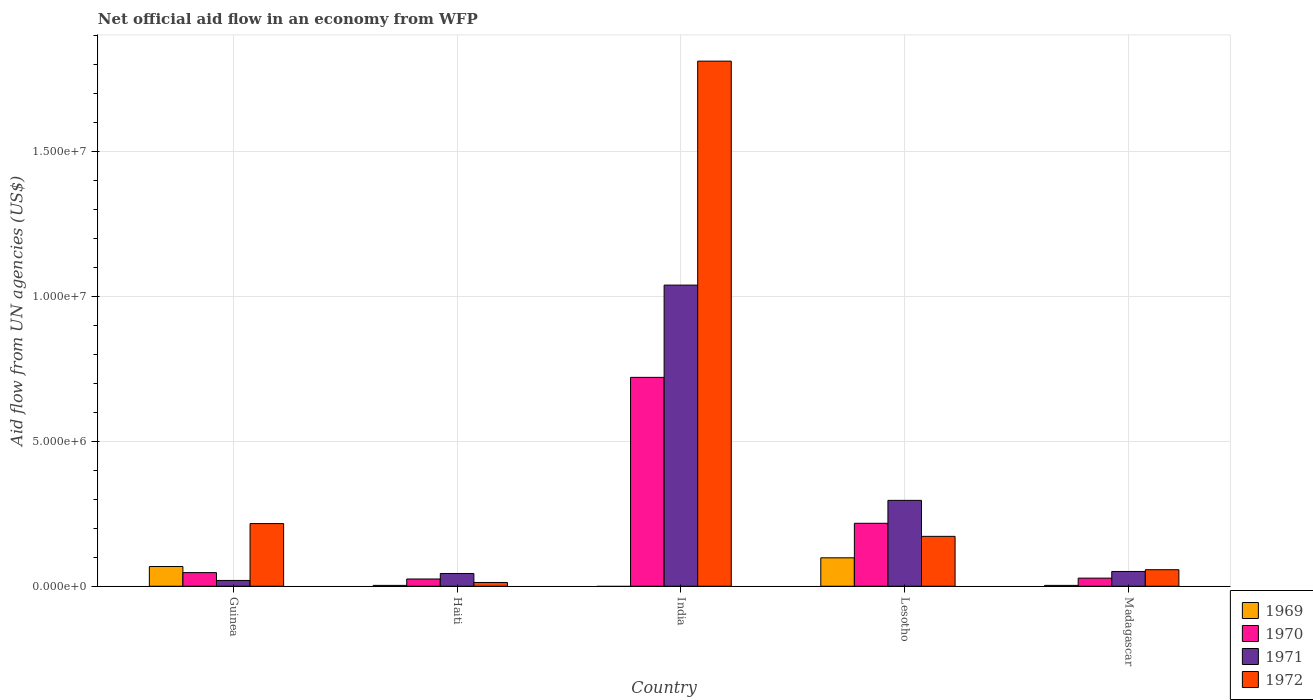How many different coloured bars are there?
Provide a succinct answer. 4. Are the number of bars per tick equal to the number of legend labels?
Your answer should be compact. No. How many bars are there on the 3rd tick from the right?
Provide a succinct answer. 3. What is the label of the 5th group of bars from the left?
Make the answer very short. Madagascar. Across all countries, what is the maximum net official aid flow in 1970?
Provide a short and direct response. 7.20e+06. Across all countries, what is the minimum net official aid flow in 1969?
Offer a very short reply. 0. In which country was the net official aid flow in 1972 maximum?
Offer a terse response. India. What is the total net official aid flow in 1970 in the graph?
Provide a short and direct response. 1.04e+07. What is the difference between the net official aid flow in 1971 in Lesotho and that in Madagascar?
Your response must be concise. 2.45e+06. What is the difference between the net official aid flow in 1969 in Lesotho and the net official aid flow in 1970 in Guinea?
Make the answer very short. 5.10e+05. What is the average net official aid flow in 1971 per country?
Your response must be concise. 2.90e+06. In how many countries, is the net official aid flow in 1972 greater than 10000000 US$?
Provide a short and direct response. 1. What is the ratio of the net official aid flow in 1969 in Lesotho to that in Madagascar?
Provide a short and direct response. 32.67. Is the net official aid flow in 1972 in Haiti less than that in India?
Ensure brevity in your answer.  Yes. What is the difference between the highest and the second highest net official aid flow in 1972?
Provide a short and direct response. 1.59e+07. What is the difference between the highest and the lowest net official aid flow in 1972?
Offer a very short reply. 1.80e+07. In how many countries, is the net official aid flow in 1972 greater than the average net official aid flow in 1972 taken over all countries?
Provide a short and direct response. 1. Is it the case that in every country, the sum of the net official aid flow in 1972 and net official aid flow in 1969 is greater than the net official aid flow in 1970?
Offer a very short reply. No. How many bars are there?
Your response must be concise. 19. How many countries are there in the graph?
Your answer should be very brief. 5. Does the graph contain grids?
Provide a short and direct response. Yes. How many legend labels are there?
Your response must be concise. 4. How are the legend labels stacked?
Ensure brevity in your answer.  Vertical. What is the title of the graph?
Your answer should be very brief. Net official aid flow in an economy from WFP. Does "1960" appear as one of the legend labels in the graph?
Provide a short and direct response. No. What is the label or title of the X-axis?
Ensure brevity in your answer.  Country. What is the label or title of the Y-axis?
Ensure brevity in your answer.  Aid flow from UN agencies (US$). What is the Aid flow from UN agencies (US$) in 1969 in Guinea?
Provide a short and direct response. 6.80e+05. What is the Aid flow from UN agencies (US$) in 1970 in Guinea?
Offer a very short reply. 4.70e+05. What is the Aid flow from UN agencies (US$) of 1971 in Guinea?
Provide a short and direct response. 2.00e+05. What is the Aid flow from UN agencies (US$) in 1972 in Guinea?
Ensure brevity in your answer.  2.16e+06. What is the Aid flow from UN agencies (US$) of 1969 in Haiti?
Your answer should be very brief. 3.00e+04. What is the Aid flow from UN agencies (US$) of 1970 in Haiti?
Your answer should be very brief. 2.50e+05. What is the Aid flow from UN agencies (US$) of 1971 in Haiti?
Your response must be concise. 4.40e+05. What is the Aid flow from UN agencies (US$) in 1972 in Haiti?
Offer a terse response. 1.30e+05. What is the Aid flow from UN agencies (US$) of 1970 in India?
Offer a terse response. 7.20e+06. What is the Aid flow from UN agencies (US$) in 1971 in India?
Provide a succinct answer. 1.04e+07. What is the Aid flow from UN agencies (US$) in 1972 in India?
Ensure brevity in your answer.  1.81e+07. What is the Aid flow from UN agencies (US$) of 1969 in Lesotho?
Give a very brief answer. 9.80e+05. What is the Aid flow from UN agencies (US$) of 1970 in Lesotho?
Provide a succinct answer. 2.17e+06. What is the Aid flow from UN agencies (US$) in 1971 in Lesotho?
Give a very brief answer. 2.96e+06. What is the Aid flow from UN agencies (US$) of 1972 in Lesotho?
Your answer should be very brief. 1.72e+06. What is the Aid flow from UN agencies (US$) of 1970 in Madagascar?
Offer a terse response. 2.80e+05. What is the Aid flow from UN agencies (US$) in 1971 in Madagascar?
Your answer should be very brief. 5.10e+05. What is the Aid flow from UN agencies (US$) of 1972 in Madagascar?
Offer a terse response. 5.70e+05. Across all countries, what is the maximum Aid flow from UN agencies (US$) in 1969?
Your answer should be very brief. 9.80e+05. Across all countries, what is the maximum Aid flow from UN agencies (US$) of 1970?
Your answer should be very brief. 7.20e+06. Across all countries, what is the maximum Aid flow from UN agencies (US$) in 1971?
Offer a very short reply. 1.04e+07. Across all countries, what is the maximum Aid flow from UN agencies (US$) of 1972?
Provide a short and direct response. 1.81e+07. Across all countries, what is the minimum Aid flow from UN agencies (US$) of 1969?
Your answer should be very brief. 0. What is the total Aid flow from UN agencies (US$) in 1969 in the graph?
Your answer should be very brief. 1.72e+06. What is the total Aid flow from UN agencies (US$) of 1970 in the graph?
Offer a very short reply. 1.04e+07. What is the total Aid flow from UN agencies (US$) in 1971 in the graph?
Offer a terse response. 1.45e+07. What is the total Aid flow from UN agencies (US$) in 1972 in the graph?
Offer a very short reply. 2.27e+07. What is the difference between the Aid flow from UN agencies (US$) in 1969 in Guinea and that in Haiti?
Offer a very short reply. 6.50e+05. What is the difference between the Aid flow from UN agencies (US$) of 1971 in Guinea and that in Haiti?
Give a very brief answer. -2.40e+05. What is the difference between the Aid flow from UN agencies (US$) of 1972 in Guinea and that in Haiti?
Provide a short and direct response. 2.03e+06. What is the difference between the Aid flow from UN agencies (US$) of 1970 in Guinea and that in India?
Make the answer very short. -6.73e+06. What is the difference between the Aid flow from UN agencies (US$) of 1971 in Guinea and that in India?
Your answer should be very brief. -1.02e+07. What is the difference between the Aid flow from UN agencies (US$) in 1972 in Guinea and that in India?
Your response must be concise. -1.59e+07. What is the difference between the Aid flow from UN agencies (US$) of 1970 in Guinea and that in Lesotho?
Your answer should be very brief. -1.70e+06. What is the difference between the Aid flow from UN agencies (US$) in 1971 in Guinea and that in Lesotho?
Make the answer very short. -2.76e+06. What is the difference between the Aid flow from UN agencies (US$) in 1969 in Guinea and that in Madagascar?
Offer a very short reply. 6.50e+05. What is the difference between the Aid flow from UN agencies (US$) in 1971 in Guinea and that in Madagascar?
Offer a terse response. -3.10e+05. What is the difference between the Aid flow from UN agencies (US$) in 1972 in Guinea and that in Madagascar?
Your answer should be very brief. 1.59e+06. What is the difference between the Aid flow from UN agencies (US$) of 1970 in Haiti and that in India?
Provide a short and direct response. -6.95e+06. What is the difference between the Aid flow from UN agencies (US$) in 1971 in Haiti and that in India?
Provide a short and direct response. -9.94e+06. What is the difference between the Aid flow from UN agencies (US$) in 1972 in Haiti and that in India?
Your answer should be compact. -1.80e+07. What is the difference between the Aid flow from UN agencies (US$) in 1969 in Haiti and that in Lesotho?
Provide a succinct answer. -9.50e+05. What is the difference between the Aid flow from UN agencies (US$) of 1970 in Haiti and that in Lesotho?
Provide a succinct answer. -1.92e+06. What is the difference between the Aid flow from UN agencies (US$) of 1971 in Haiti and that in Lesotho?
Your answer should be compact. -2.52e+06. What is the difference between the Aid flow from UN agencies (US$) of 1972 in Haiti and that in Lesotho?
Ensure brevity in your answer.  -1.59e+06. What is the difference between the Aid flow from UN agencies (US$) in 1969 in Haiti and that in Madagascar?
Keep it short and to the point. 0. What is the difference between the Aid flow from UN agencies (US$) of 1972 in Haiti and that in Madagascar?
Your response must be concise. -4.40e+05. What is the difference between the Aid flow from UN agencies (US$) of 1970 in India and that in Lesotho?
Provide a succinct answer. 5.03e+06. What is the difference between the Aid flow from UN agencies (US$) in 1971 in India and that in Lesotho?
Provide a succinct answer. 7.42e+06. What is the difference between the Aid flow from UN agencies (US$) in 1972 in India and that in Lesotho?
Give a very brief answer. 1.64e+07. What is the difference between the Aid flow from UN agencies (US$) in 1970 in India and that in Madagascar?
Provide a succinct answer. 6.92e+06. What is the difference between the Aid flow from UN agencies (US$) in 1971 in India and that in Madagascar?
Offer a very short reply. 9.87e+06. What is the difference between the Aid flow from UN agencies (US$) of 1972 in India and that in Madagascar?
Make the answer very short. 1.75e+07. What is the difference between the Aid flow from UN agencies (US$) in 1969 in Lesotho and that in Madagascar?
Offer a very short reply. 9.50e+05. What is the difference between the Aid flow from UN agencies (US$) of 1970 in Lesotho and that in Madagascar?
Offer a very short reply. 1.89e+06. What is the difference between the Aid flow from UN agencies (US$) of 1971 in Lesotho and that in Madagascar?
Offer a very short reply. 2.45e+06. What is the difference between the Aid flow from UN agencies (US$) of 1972 in Lesotho and that in Madagascar?
Make the answer very short. 1.15e+06. What is the difference between the Aid flow from UN agencies (US$) of 1969 in Guinea and the Aid flow from UN agencies (US$) of 1970 in Haiti?
Give a very brief answer. 4.30e+05. What is the difference between the Aid flow from UN agencies (US$) of 1969 in Guinea and the Aid flow from UN agencies (US$) of 1971 in Haiti?
Your response must be concise. 2.40e+05. What is the difference between the Aid flow from UN agencies (US$) in 1969 in Guinea and the Aid flow from UN agencies (US$) in 1972 in Haiti?
Make the answer very short. 5.50e+05. What is the difference between the Aid flow from UN agencies (US$) in 1970 in Guinea and the Aid flow from UN agencies (US$) in 1972 in Haiti?
Provide a short and direct response. 3.40e+05. What is the difference between the Aid flow from UN agencies (US$) in 1971 in Guinea and the Aid flow from UN agencies (US$) in 1972 in Haiti?
Offer a very short reply. 7.00e+04. What is the difference between the Aid flow from UN agencies (US$) in 1969 in Guinea and the Aid flow from UN agencies (US$) in 1970 in India?
Provide a short and direct response. -6.52e+06. What is the difference between the Aid flow from UN agencies (US$) in 1969 in Guinea and the Aid flow from UN agencies (US$) in 1971 in India?
Ensure brevity in your answer.  -9.70e+06. What is the difference between the Aid flow from UN agencies (US$) in 1969 in Guinea and the Aid flow from UN agencies (US$) in 1972 in India?
Provide a short and direct response. -1.74e+07. What is the difference between the Aid flow from UN agencies (US$) of 1970 in Guinea and the Aid flow from UN agencies (US$) of 1971 in India?
Offer a very short reply. -9.91e+06. What is the difference between the Aid flow from UN agencies (US$) of 1970 in Guinea and the Aid flow from UN agencies (US$) of 1972 in India?
Your answer should be compact. -1.76e+07. What is the difference between the Aid flow from UN agencies (US$) in 1971 in Guinea and the Aid flow from UN agencies (US$) in 1972 in India?
Provide a succinct answer. -1.79e+07. What is the difference between the Aid flow from UN agencies (US$) of 1969 in Guinea and the Aid flow from UN agencies (US$) of 1970 in Lesotho?
Your answer should be very brief. -1.49e+06. What is the difference between the Aid flow from UN agencies (US$) of 1969 in Guinea and the Aid flow from UN agencies (US$) of 1971 in Lesotho?
Provide a succinct answer. -2.28e+06. What is the difference between the Aid flow from UN agencies (US$) of 1969 in Guinea and the Aid flow from UN agencies (US$) of 1972 in Lesotho?
Ensure brevity in your answer.  -1.04e+06. What is the difference between the Aid flow from UN agencies (US$) of 1970 in Guinea and the Aid flow from UN agencies (US$) of 1971 in Lesotho?
Provide a succinct answer. -2.49e+06. What is the difference between the Aid flow from UN agencies (US$) of 1970 in Guinea and the Aid flow from UN agencies (US$) of 1972 in Lesotho?
Offer a terse response. -1.25e+06. What is the difference between the Aid flow from UN agencies (US$) of 1971 in Guinea and the Aid flow from UN agencies (US$) of 1972 in Lesotho?
Ensure brevity in your answer.  -1.52e+06. What is the difference between the Aid flow from UN agencies (US$) in 1969 in Guinea and the Aid flow from UN agencies (US$) in 1970 in Madagascar?
Provide a succinct answer. 4.00e+05. What is the difference between the Aid flow from UN agencies (US$) in 1969 in Guinea and the Aid flow from UN agencies (US$) in 1972 in Madagascar?
Your answer should be very brief. 1.10e+05. What is the difference between the Aid flow from UN agencies (US$) of 1970 in Guinea and the Aid flow from UN agencies (US$) of 1971 in Madagascar?
Your answer should be very brief. -4.00e+04. What is the difference between the Aid flow from UN agencies (US$) in 1970 in Guinea and the Aid flow from UN agencies (US$) in 1972 in Madagascar?
Keep it short and to the point. -1.00e+05. What is the difference between the Aid flow from UN agencies (US$) of 1971 in Guinea and the Aid flow from UN agencies (US$) of 1972 in Madagascar?
Offer a very short reply. -3.70e+05. What is the difference between the Aid flow from UN agencies (US$) in 1969 in Haiti and the Aid flow from UN agencies (US$) in 1970 in India?
Offer a very short reply. -7.17e+06. What is the difference between the Aid flow from UN agencies (US$) in 1969 in Haiti and the Aid flow from UN agencies (US$) in 1971 in India?
Offer a terse response. -1.04e+07. What is the difference between the Aid flow from UN agencies (US$) of 1969 in Haiti and the Aid flow from UN agencies (US$) of 1972 in India?
Keep it short and to the point. -1.81e+07. What is the difference between the Aid flow from UN agencies (US$) in 1970 in Haiti and the Aid flow from UN agencies (US$) in 1971 in India?
Offer a terse response. -1.01e+07. What is the difference between the Aid flow from UN agencies (US$) in 1970 in Haiti and the Aid flow from UN agencies (US$) in 1972 in India?
Make the answer very short. -1.78e+07. What is the difference between the Aid flow from UN agencies (US$) of 1971 in Haiti and the Aid flow from UN agencies (US$) of 1972 in India?
Provide a succinct answer. -1.77e+07. What is the difference between the Aid flow from UN agencies (US$) in 1969 in Haiti and the Aid flow from UN agencies (US$) in 1970 in Lesotho?
Provide a short and direct response. -2.14e+06. What is the difference between the Aid flow from UN agencies (US$) of 1969 in Haiti and the Aid flow from UN agencies (US$) of 1971 in Lesotho?
Ensure brevity in your answer.  -2.93e+06. What is the difference between the Aid flow from UN agencies (US$) of 1969 in Haiti and the Aid flow from UN agencies (US$) of 1972 in Lesotho?
Offer a terse response. -1.69e+06. What is the difference between the Aid flow from UN agencies (US$) of 1970 in Haiti and the Aid flow from UN agencies (US$) of 1971 in Lesotho?
Offer a terse response. -2.71e+06. What is the difference between the Aid flow from UN agencies (US$) of 1970 in Haiti and the Aid flow from UN agencies (US$) of 1972 in Lesotho?
Offer a terse response. -1.47e+06. What is the difference between the Aid flow from UN agencies (US$) of 1971 in Haiti and the Aid flow from UN agencies (US$) of 1972 in Lesotho?
Provide a short and direct response. -1.28e+06. What is the difference between the Aid flow from UN agencies (US$) of 1969 in Haiti and the Aid flow from UN agencies (US$) of 1971 in Madagascar?
Provide a succinct answer. -4.80e+05. What is the difference between the Aid flow from UN agencies (US$) in 1969 in Haiti and the Aid flow from UN agencies (US$) in 1972 in Madagascar?
Your answer should be compact. -5.40e+05. What is the difference between the Aid flow from UN agencies (US$) in 1970 in Haiti and the Aid flow from UN agencies (US$) in 1972 in Madagascar?
Your answer should be compact. -3.20e+05. What is the difference between the Aid flow from UN agencies (US$) of 1970 in India and the Aid flow from UN agencies (US$) of 1971 in Lesotho?
Make the answer very short. 4.24e+06. What is the difference between the Aid flow from UN agencies (US$) in 1970 in India and the Aid flow from UN agencies (US$) in 1972 in Lesotho?
Provide a short and direct response. 5.48e+06. What is the difference between the Aid flow from UN agencies (US$) of 1971 in India and the Aid flow from UN agencies (US$) of 1972 in Lesotho?
Make the answer very short. 8.66e+06. What is the difference between the Aid flow from UN agencies (US$) in 1970 in India and the Aid flow from UN agencies (US$) in 1971 in Madagascar?
Provide a short and direct response. 6.69e+06. What is the difference between the Aid flow from UN agencies (US$) in 1970 in India and the Aid flow from UN agencies (US$) in 1972 in Madagascar?
Keep it short and to the point. 6.63e+06. What is the difference between the Aid flow from UN agencies (US$) in 1971 in India and the Aid flow from UN agencies (US$) in 1972 in Madagascar?
Offer a terse response. 9.81e+06. What is the difference between the Aid flow from UN agencies (US$) in 1969 in Lesotho and the Aid flow from UN agencies (US$) in 1971 in Madagascar?
Your response must be concise. 4.70e+05. What is the difference between the Aid flow from UN agencies (US$) in 1969 in Lesotho and the Aid flow from UN agencies (US$) in 1972 in Madagascar?
Offer a very short reply. 4.10e+05. What is the difference between the Aid flow from UN agencies (US$) of 1970 in Lesotho and the Aid flow from UN agencies (US$) of 1971 in Madagascar?
Offer a terse response. 1.66e+06. What is the difference between the Aid flow from UN agencies (US$) of 1970 in Lesotho and the Aid flow from UN agencies (US$) of 1972 in Madagascar?
Offer a terse response. 1.60e+06. What is the difference between the Aid flow from UN agencies (US$) of 1971 in Lesotho and the Aid flow from UN agencies (US$) of 1972 in Madagascar?
Your response must be concise. 2.39e+06. What is the average Aid flow from UN agencies (US$) of 1969 per country?
Provide a short and direct response. 3.44e+05. What is the average Aid flow from UN agencies (US$) in 1970 per country?
Keep it short and to the point. 2.07e+06. What is the average Aid flow from UN agencies (US$) in 1971 per country?
Your answer should be compact. 2.90e+06. What is the average Aid flow from UN agencies (US$) in 1972 per country?
Give a very brief answer. 4.54e+06. What is the difference between the Aid flow from UN agencies (US$) in 1969 and Aid flow from UN agencies (US$) in 1971 in Guinea?
Offer a terse response. 4.80e+05. What is the difference between the Aid flow from UN agencies (US$) in 1969 and Aid flow from UN agencies (US$) in 1972 in Guinea?
Keep it short and to the point. -1.48e+06. What is the difference between the Aid flow from UN agencies (US$) in 1970 and Aid flow from UN agencies (US$) in 1971 in Guinea?
Keep it short and to the point. 2.70e+05. What is the difference between the Aid flow from UN agencies (US$) of 1970 and Aid flow from UN agencies (US$) of 1972 in Guinea?
Your answer should be very brief. -1.69e+06. What is the difference between the Aid flow from UN agencies (US$) of 1971 and Aid flow from UN agencies (US$) of 1972 in Guinea?
Offer a terse response. -1.96e+06. What is the difference between the Aid flow from UN agencies (US$) of 1969 and Aid flow from UN agencies (US$) of 1970 in Haiti?
Offer a very short reply. -2.20e+05. What is the difference between the Aid flow from UN agencies (US$) in 1969 and Aid flow from UN agencies (US$) in 1971 in Haiti?
Keep it short and to the point. -4.10e+05. What is the difference between the Aid flow from UN agencies (US$) in 1969 and Aid flow from UN agencies (US$) in 1972 in Haiti?
Your answer should be very brief. -1.00e+05. What is the difference between the Aid flow from UN agencies (US$) in 1970 and Aid flow from UN agencies (US$) in 1971 in Haiti?
Your answer should be very brief. -1.90e+05. What is the difference between the Aid flow from UN agencies (US$) in 1970 and Aid flow from UN agencies (US$) in 1972 in Haiti?
Your answer should be compact. 1.20e+05. What is the difference between the Aid flow from UN agencies (US$) in 1970 and Aid flow from UN agencies (US$) in 1971 in India?
Your response must be concise. -3.18e+06. What is the difference between the Aid flow from UN agencies (US$) of 1970 and Aid flow from UN agencies (US$) of 1972 in India?
Offer a terse response. -1.09e+07. What is the difference between the Aid flow from UN agencies (US$) in 1971 and Aid flow from UN agencies (US$) in 1972 in India?
Your answer should be very brief. -7.72e+06. What is the difference between the Aid flow from UN agencies (US$) in 1969 and Aid flow from UN agencies (US$) in 1970 in Lesotho?
Ensure brevity in your answer.  -1.19e+06. What is the difference between the Aid flow from UN agencies (US$) in 1969 and Aid flow from UN agencies (US$) in 1971 in Lesotho?
Keep it short and to the point. -1.98e+06. What is the difference between the Aid flow from UN agencies (US$) in 1969 and Aid flow from UN agencies (US$) in 1972 in Lesotho?
Make the answer very short. -7.40e+05. What is the difference between the Aid flow from UN agencies (US$) in 1970 and Aid flow from UN agencies (US$) in 1971 in Lesotho?
Ensure brevity in your answer.  -7.90e+05. What is the difference between the Aid flow from UN agencies (US$) in 1970 and Aid flow from UN agencies (US$) in 1972 in Lesotho?
Your answer should be very brief. 4.50e+05. What is the difference between the Aid flow from UN agencies (US$) of 1971 and Aid flow from UN agencies (US$) of 1972 in Lesotho?
Ensure brevity in your answer.  1.24e+06. What is the difference between the Aid flow from UN agencies (US$) in 1969 and Aid flow from UN agencies (US$) in 1970 in Madagascar?
Provide a short and direct response. -2.50e+05. What is the difference between the Aid flow from UN agencies (US$) in 1969 and Aid flow from UN agencies (US$) in 1971 in Madagascar?
Your answer should be very brief. -4.80e+05. What is the difference between the Aid flow from UN agencies (US$) of 1969 and Aid flow from UN agencies (US$) of 1972 in Madagascar?
Your answer should be compact. -5.40e+05. What is the ratio of the Aid flow from UN agencies (US$) in 1969 in Guinea to that in Haiti?
Provide a short and direct response. 22.67. What is the ratio of the Aid flow from UN agencies (US$) in 1970 in Guinea to that in Haiti?
Offer a very short reply. 1.88. What is the ratio of the Aid flow from UN agencies (US$) of 1971 in Guinea to that in Haiti?
Make the answer very short. 0.45. What is the ratio of the Aid flow from UN agencies (US$) in 1972 in Guinea to that in Haiti?
Offer a terse response. 16.62. What is the ratio of the Aid flow from UN agencies (US$) of 1970 in Guinea to that in India?
Your answer should be compact. 0.07. What is the ratio of the Aid flow from UN agencies (US$) of 1971 in Guinea to that in India?
Your response must be concise. 0.02. What is the ratio of the Aid flow from UN agencies (US$) of 1972 in Guinea to that in India?
Provide a succinct answer. 0.12. What is the ratio of the Aid flow from UN agencies (US$) in 1969 in Guinea to that in Lesotho?
Provide a short and direct response. 0.69. What is the ratio of the Aid flow from UN agencies (US$) of 1970 in Guinea to that in Lesotho?
Your answer should be very brief. 0.22. What is the ratio of the Aid flow from UN agencies (US$) in 1971 in Guinea to that in Lesotho?
Make the answer very short. 0.07. What is the ratio of the Aid flow from UN agencies (US$) in 1972 in Guinea to that in Lesotho?
Make the answer very short. 1.26. What is the ratio of the Aid flow from UN agencies (US$) in 1969 in Guinea to that in Madagascar?
Make the answer very short. 22.67. What is the ratio of the Aid flow from UN agencies (US$) in 1970 in Guinea to that in Madagascar?
Make the answer very short. 1.68. What is the ratio of the Aid flow from UN agencies (US$) of 1971 in Guinea to that in Madagascar?
Provide a succinct answer. 0.39. What is the ratio of the Aid flow from UN agencies (US$) in 1972 in Guinea to that in Madagascar?
Your answer should be very brief. 3.79. What is the ratio of the Aid flow from UN agencies (US$) of 1970 in Haiti to that in India?
Ensure brevity in your answer.  0.03. What is the ratio of the Aid flow from UN agencies (US$) of 1971 in Haiti to that in India?
Give a very brief answer. 0.04. What is the ratio of the Aid flow from UN agencies (US$) in 1972 in Haiti to that in India?
Ensure brevity in your answer.  0.01. What is the ratio of the Aid flow from UN agencies (US$) of 1969 in Haiti to that in Lesotho?
Your answer should be compact. 0.03. What is the ratio of the Aid flow from UN agencies (US$) in 1970 in Haiti to that in Lesotho?
Your answer should be very brief. 0.12. What is the ratio of the Aid flow from UN agencies (US$) in 1971 in Haiti to that in Lesotho?
Provide a short and direct response. 0.15. What is the ratio of the Aid flow from UN agencies (US$) in 1972 in Haiti to that in Lesotho?
Your answer should be very brief. 0.08. What is the ratio of the Aid flow from UN agencies (US$) in 1970 in Haiti to that in Madagascar?
Provide a short and direct response. 0.89. What is the ratio of the Aid flow from UN agencies (US$) of 1971 in Haiti to that in Madagascar?
Your answer should be very brief. 0.86. What is the ratio of the Aid flow from UN agencies (US$) in 1972 in Haiti to that in Madagascar?
Your answer should be very brief. 0.23. What is the ratio of the Aid flow from UN agencies (US$) of 1970 in India to that in Lesotho?
Provide a succinct answer. 3.32. What is the ratio of the Aid flow from UN agencies (US$) of 1971 in India to that in Lesotho?
Your answer should be very brief. 3.51. What is the ratio of the Aid flow from UN agencies (US$) of 1972 in India to that in Lesotho?
Offer a very short reply. 10.52. What is the ratio of the Aid flow from UN agencies (US$) of 1970 in India to that in Madagascar?
Ensure brevity in your answer.  25.71. What is the ratio of the Aid flow from UN agencies (US$) in 1971 in India to that in Madagascar?
Offer a very short reply. 20.35. What is the ratio of the Aid flow from UN agencies (US$) in 1972 in India to that in Madagascar?
Your response must be concise. 31.75. What is the ratio of the Aid flow from UN agencies (US$) in 1969 in Lesotho to that in Madagascar?
Provide a succinct answer. 32.67. What is the ratio of the Aid flow from UN agencies (US$) in 1970 in Lesotho to that in Madagascar?
Your response must be concise. 7.75. What is the ratio of the Aid flow from UN agencies (US$) of 1971 in Lesotho to that in Madagascar?
Ensure brevity in your answer.  5.8. What is the ratio of the Aid flow from UN agencies (US$) of 1972 in Lesotho to that in Madagascar?
Offer a terse response. 3.02. What is the difference between the highest and the second highest Aid flow from UN agencies (US$) in 1970?
Give a very brief answer. 5.03e+06. What is the difference between the highest and the second highest Aid flow from UN agencies (US$) of 1971?
Keep it short and to the point. 7.42e+06. What is the difference between the highest and the second highest Aid flow from UN agencies (US$) in 1972?
Offer a very short reply. 1.59e+07. What is the difference between the highest and the lowest Aid flow from UN agencies (US$) in 1969?
Your answer should be compact. 9.80e+05. What is the difference between the highest and the lowest Aid flow from UN agencies (US$) of 1970?
Ensure brevity in your answer.  6.95e+06. What is the difference between the highest and the lowest Aid flow from UN agencies (US$) in 1971?
Offer a terse response. 1.02e+07. What is the difference between the highest and the lowest Aid flow from UN agencies (US$) in 1972?
Offer a terse response. 1.80e+07. 